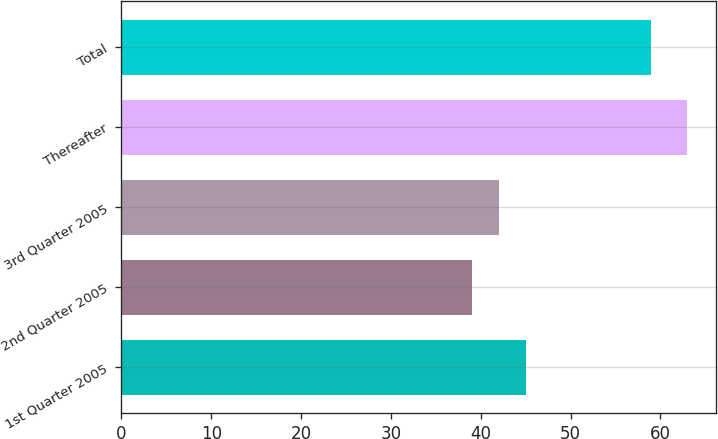<chart> <loc_0><loc_0><loc_500><loc_500><bar_chart><fcel>1st Quarter 2005<fcel>2nd Quarter 2005<fcel>3rd Quarter 2005<fcel>Thereafter<fcel>Total<nl><fcel>45<fcel>39<fcel>42<fcel>63<fcel>59<nl></chart> 